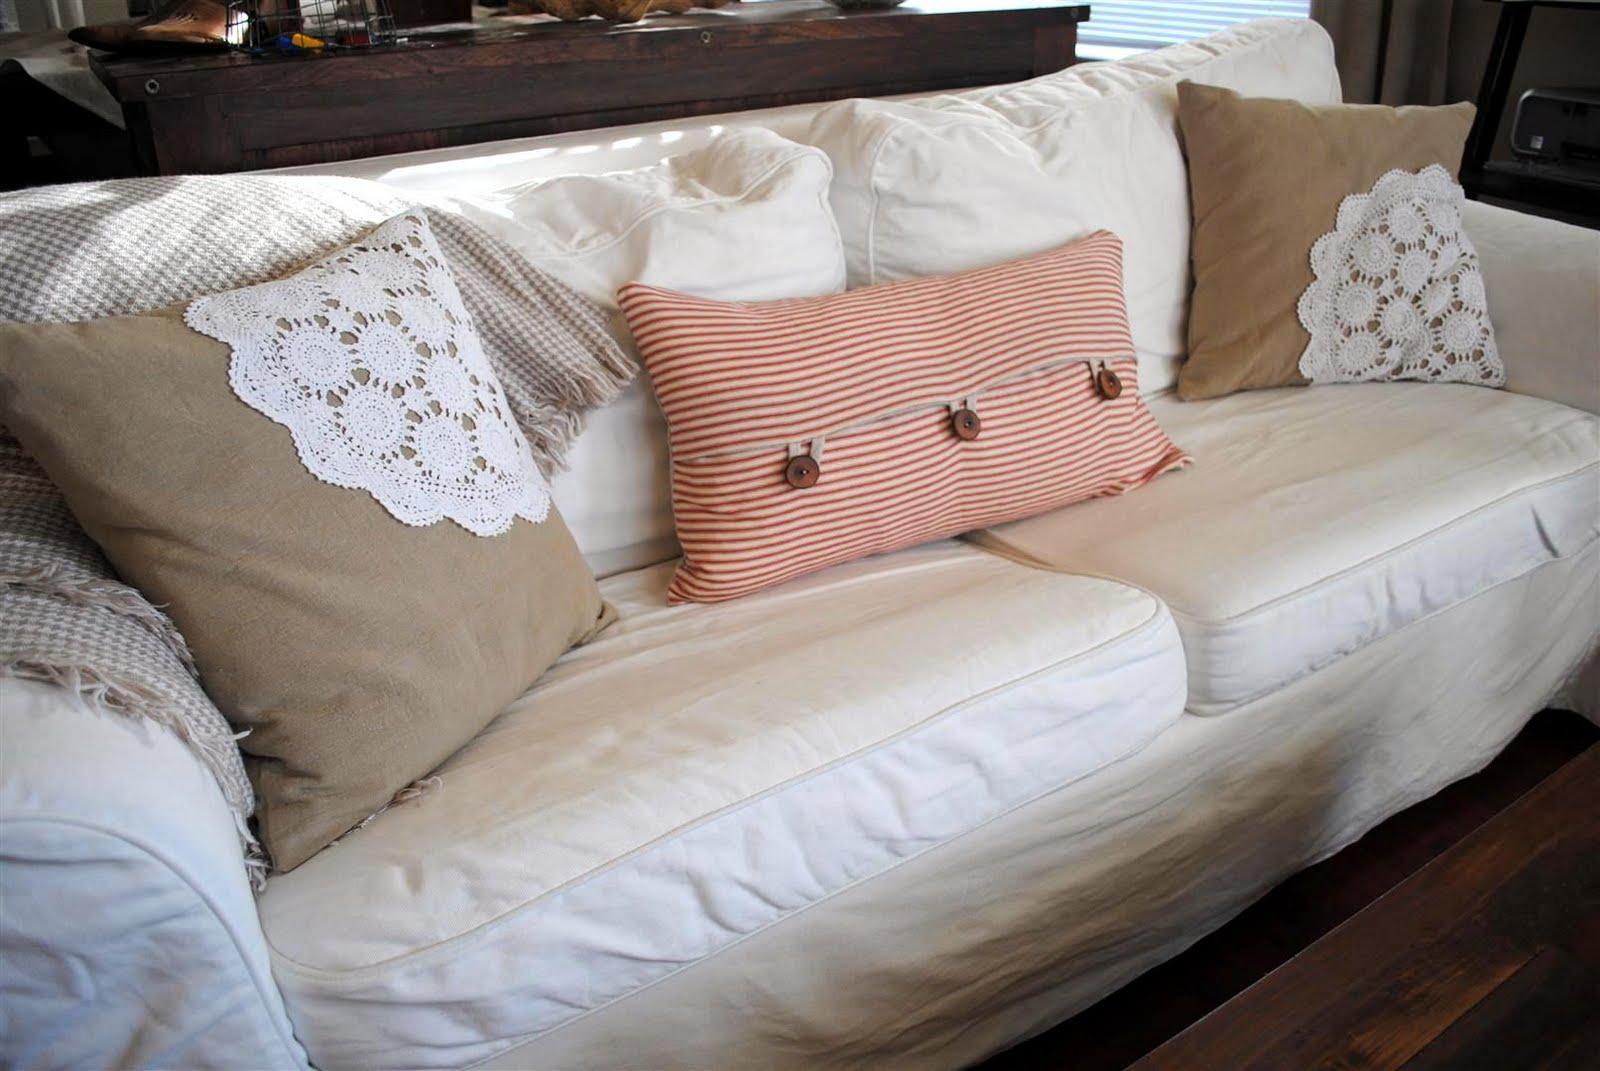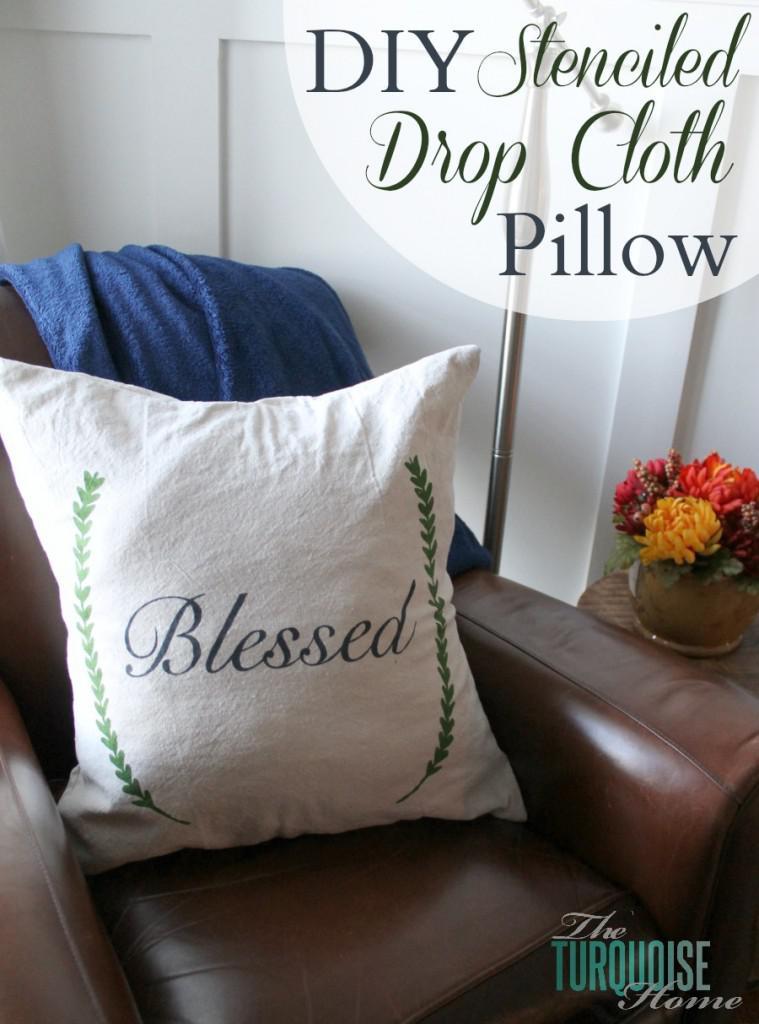The first image is the image on the left, the second image is the image on the right. For the images shown, is this caption "A square pillow with dark stripes down the middle is overlapping another pillow with stripes and displayed on a woodgrain surface, in the right image." true? Answer yes or no. No. The first image is the image on the left, the second image is the image on the right. Examine the images to the left and right. Is the description "There are two white pillows one in the back with two small strips pattern that repeat itself and a top pillow with 3 strips with the middle being the biggest." accurate? Answer yes or no. No. 